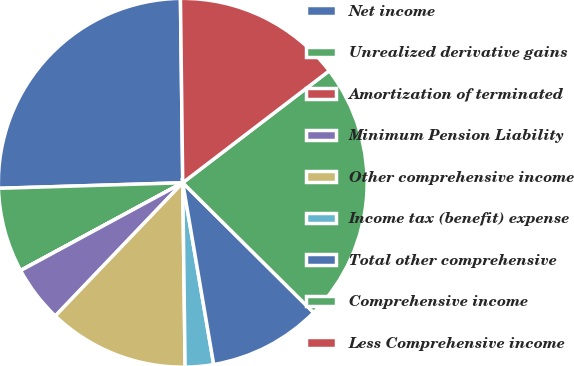Convert chart. <chart><loc_0><loc_0><loc_500><loc_500><pie_chart><fcel>Net income<fcel>Unrealized derivative gains<fcel>Amortization of terminated<fcel>Minimum Pension Liability<fcel>Other comprehensive income<fcel>Income tax (benefit) expense<fcel>Total other comprehensive<fcel>Comprehensive income<fcel>Less Comprehensive income<nl><fcel>25.28%<fcel>7.41%<fcel>0.01%<fcel>4.95%<fcel>12.35%<fcel>2.48%<fcel>9.88%<fcel>22.82%<fcel>14.81%<nl></chart> 